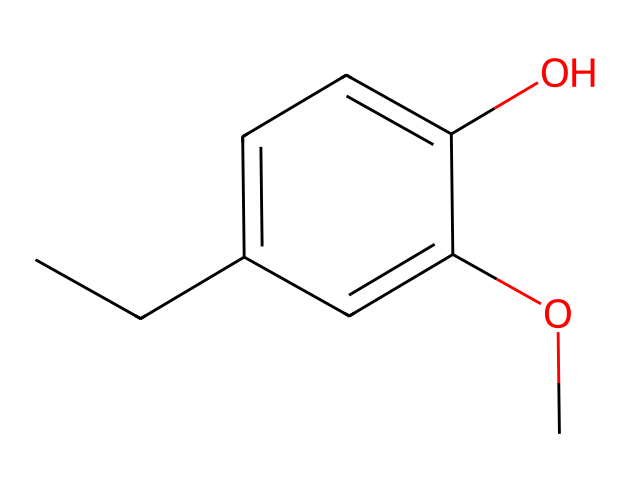What is the functional group present in eugenol? The structure contains a hydroxyl group (–OH) attached to the aromatic ring, which identifies it as a phenol.
Answer: hydroxyl group How many carbon atoms are in eugenol? By counting the 'C' symbols in the SMILES representation, there are 10 carbon atoms in total.
Answer: 10 How many oxygen atoms are in eugenol? The SMILES notation shows two 'O' symbols, indicating that eugenol contains two oxygen atoms.
Answer: 2 What type of compound is eugenol classified as? Eugenol has a hydroxyl group attached to a benzene ring, classifying it as a phenolic compound.
Answer: phenolic What is the molecular formula of eugenol based on its structure? By determining the number of each type of atom represented in the SMILES, we find that it is C10H12O2.
Answer: C10H12O2 What structural feature of eugenol contributes to its aroma? The presence of the methoxy group (–OCH3) attached to the aromatic ring contributes to its distinctive clove-like aroma.
Answer: methoxy group What type of bonding is found in eugenol? The structure has single and double bonds typical of organic compounds, specifically conjugated double bonds in the aromatic ring.
Answer: covalent bonding 